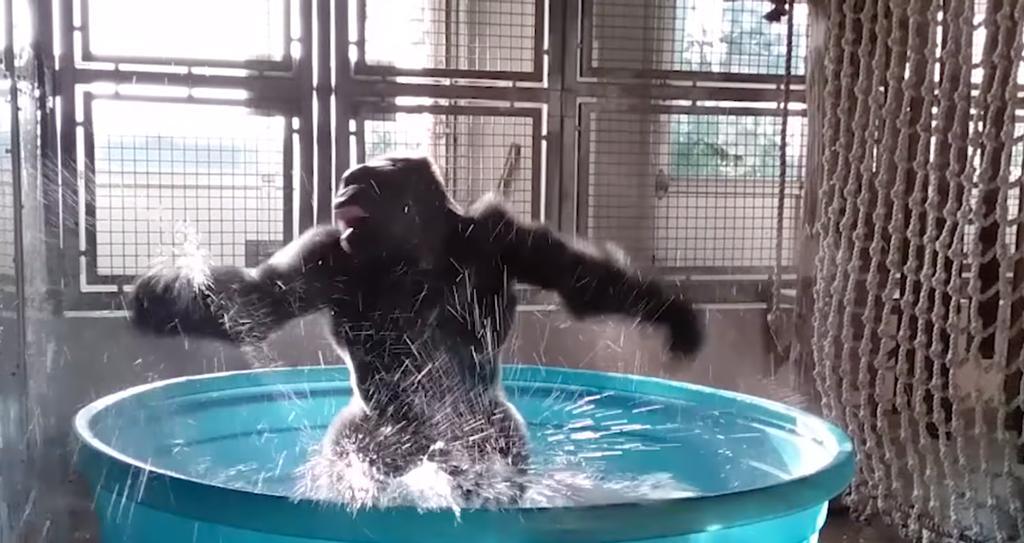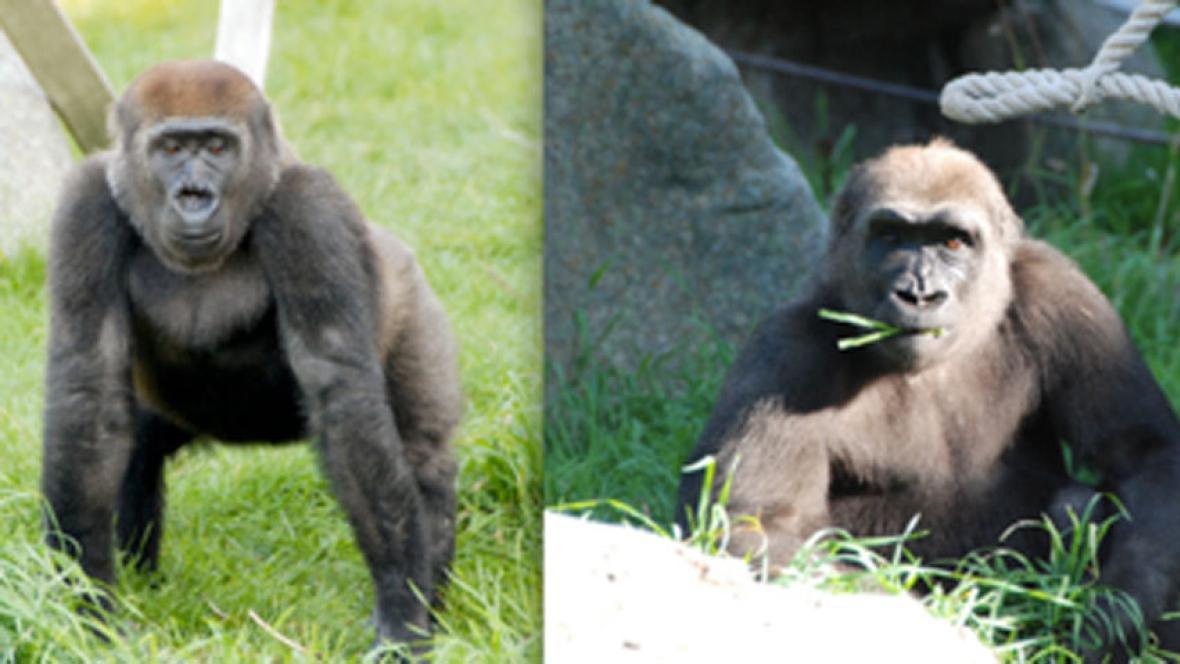The first image is the image on the left, the second image is the image on the right. Assess this claim about the two images: "An image shows one forward-turned gorilla standing in a small blue pool splashing water and posed with both arms outstretched horizontally.". Correct or not? Answer yes or no. Yes. 